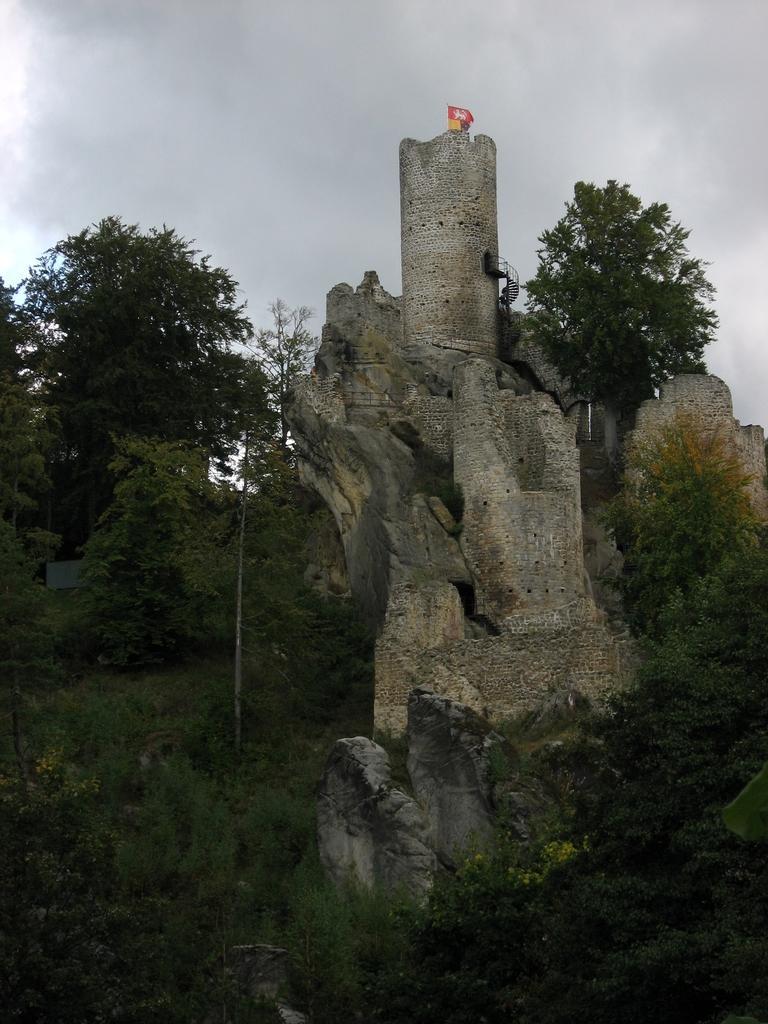In one or two sentences, can you explain what this image depicts? In this picture we can see few trees, rocks and a fort. 